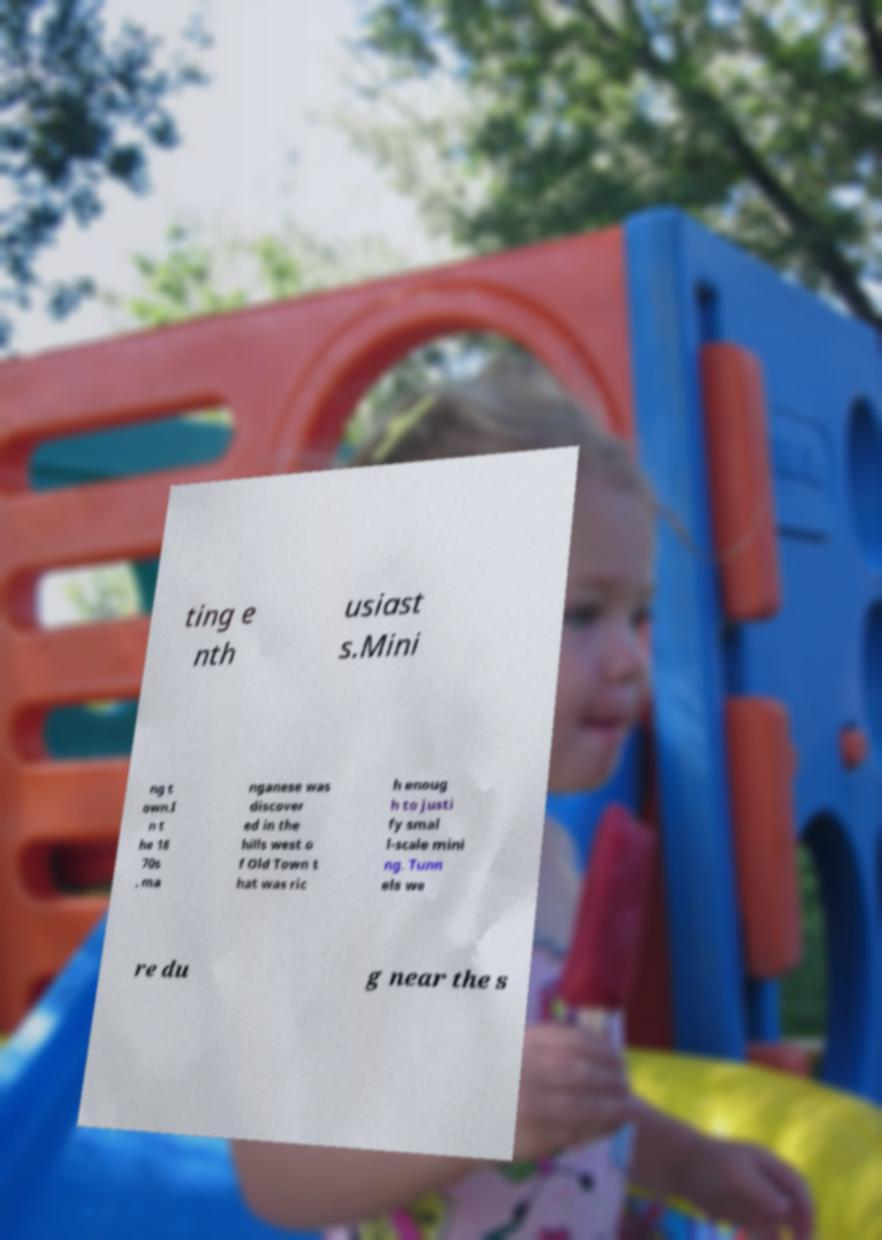What messages or text are displayed in this image? I need them in a readable, typed format. ting e nth usiast s.Mini ng t own.I n t he 18 70s , ma nganese was discover ed in the hills west o f Old Town t hat was ric h enoug h to justi fy smal l-scale mini ng. Tunn els we re du g near the s 